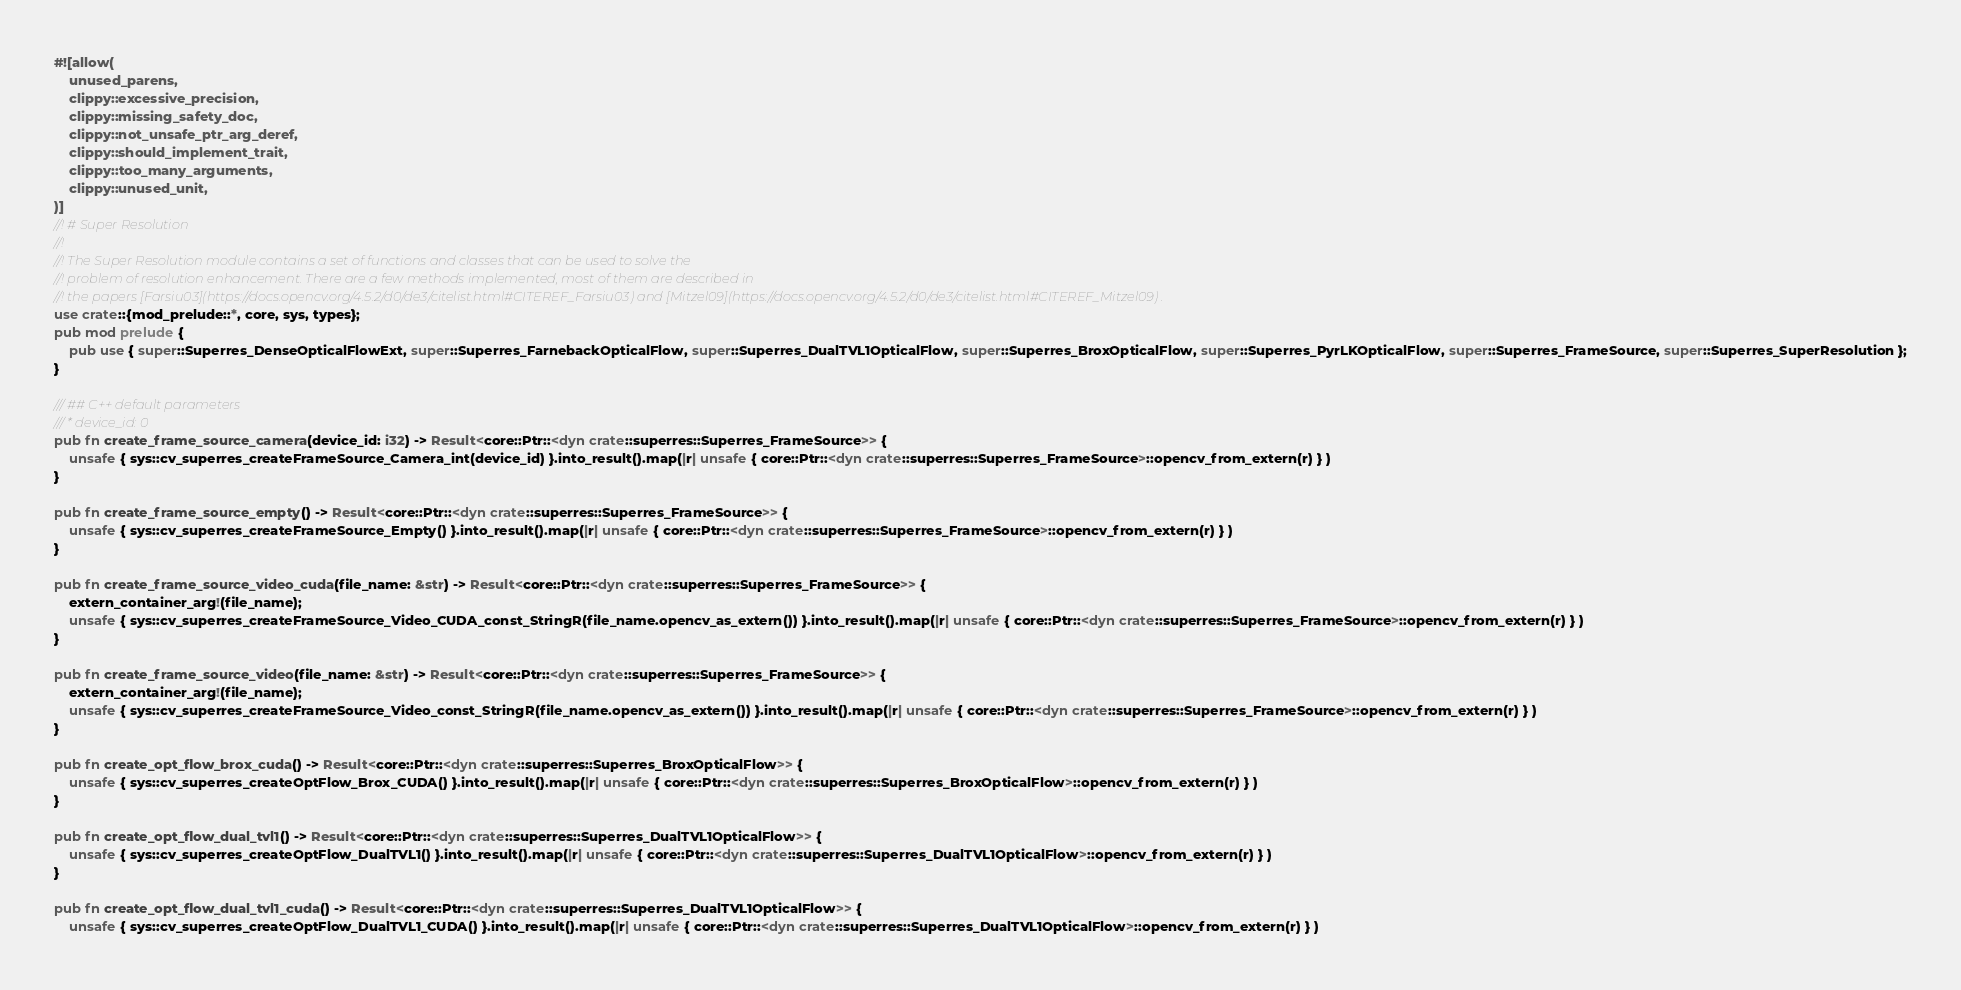<code> <loc_0><loc_0><loc_500><loc_500><_Rust_>#![allow(
	unused_parens,
	clippy::excessive_precision,
	clippy::missing_safety_doc,
	clippy::not_unsafe_ptr_arg_deref,
	clippy::should_implement_trait,
	clippy::too_many_arguments,
	clippy::unused_unit,
)]
//! # Super Resolution
//! 
//! The Super Resolution module contains a set of functions and classes that can be used to solve the
//! problem of resolution enhancement. There are a few methods implemented, most of them are described in
//! the papers [Farsiu03](https://docs.opencv.org/4.5.2/d0/de3/citelist.html#CITEREF_Farsiu03) and [Mitzel09](https://docs.opencv.org/4.5.2/d0/de3/citelist.html#CITEREF_Mitzel09) .
use crate::{mod_prelude::*, core, sys, types};
pub mod prelude {
	pub use { super::Superres_DenseOpticalFlowExt, super::Superres_FarnebackOpticalFlow, super::Superres_DualTVL1OpticalFlow, super::Superres_BroxOpticalFlow, super::Superres_PyrLKOpticalFlow, super::Superres_FrameSource, super::Superres_SuperResolution };
}

/// ## C++ default parameters
/// * device_id: 0
pub fn create_frame_source_camera(device_id: i32) -> Result<core::Ptr::<dyn crate::superres::Superres_FrameSource>> {
	unsafe { sys::cv_superres_createFrameSource_Camera_int(device_id) }.into_result().map(|r| unsafe { core::Ptr::<dyn crate::superres::Superres_FrameSource>::opencv_from_extern(r) } )
}

pub fn create_frame_source_empty() -> Result<core::Ptr::<dyn crate::superres::Superres_FrameSource>> {
	unsafe { sys::cv_superres_createFrameSource_Empty() }.into_result().map(|r| unsafe { core::Ptr::<dyn crate::superres::Superres_FrameSource>::opencv_from_extern(r) } )
}

pub fn create_frame_source_video_cuda(file_name: &str) -> Result<core::Ptr::<dyn crate::superres::Superres_FrameSource>> {
	extern_container_arg!(file_name);
	unsafe { sys::cv_superres_createFrameSource_Video_CUDA_const_StringR(file_name.opencv_as_extern()) }.into_result().map(|r| unsafe { core::Ptr::<dyn crate::superres::Superres_FrameSource>::opencv_from_extern(r) } )
}

pub fn create_frame_source_video(file_name: &str) -> Result<core::Ptr::<dyn crate::superres::Superres_FrameSource>> {
	extern_container_arg!(file_name);
	unsafe { sys::cv_superres_createFrameSource_Video_const_StringR(file_name.opencv_as_extern()) }.into_result().map(|r| unsafe { core::Ptr::<dyn crate::superres::Superres_FrameSource>::opencv_from_extern(r) } )
}

pub fn create_opt_flow_brox_cuda() -> Result<core::Ptr::<dyn crate::superres::Superres_BroxOpticalFlow>> {
	unsafe { sys::cv_superres_createOptFlow_Brox_CUDA() }.into_result().map(|r| unsafe { core::Ptr::<dyn crate::superres::Superres_BroxOpticalFlow>::opencv_from_extern(r) } )
}

pub fn create_opt_flow_dual_tvl1() -> Result<core::Ptr::<dyn crate::superres::Superres_DualTVL1OpticalFlow>> {
	unsafe { sys::cv_superres_createOptFlow_DualTVL1() }.into_result().map(|r| unsafe { core::Ptr::<dyn crate::superres::Superres_DualTVL1OpticalFlow>::opencv_from_extern(r) } )
}

pub fn create_opt_flow_dual_tvl1_cuda() -> Result<core::Ptr::<dyn crate::superres::Superres_DualTVL1OpticalFlow>> {
	unsafe { sys::cv_superres_createOptFlow_DualTVL1_CUDA() }.into_result().map(|r| unsafe { core::Ptr::<dyn crate::superres::Superres_DualTVL1OpticalFlow>::opencv_from_extern(r) } )</code> 